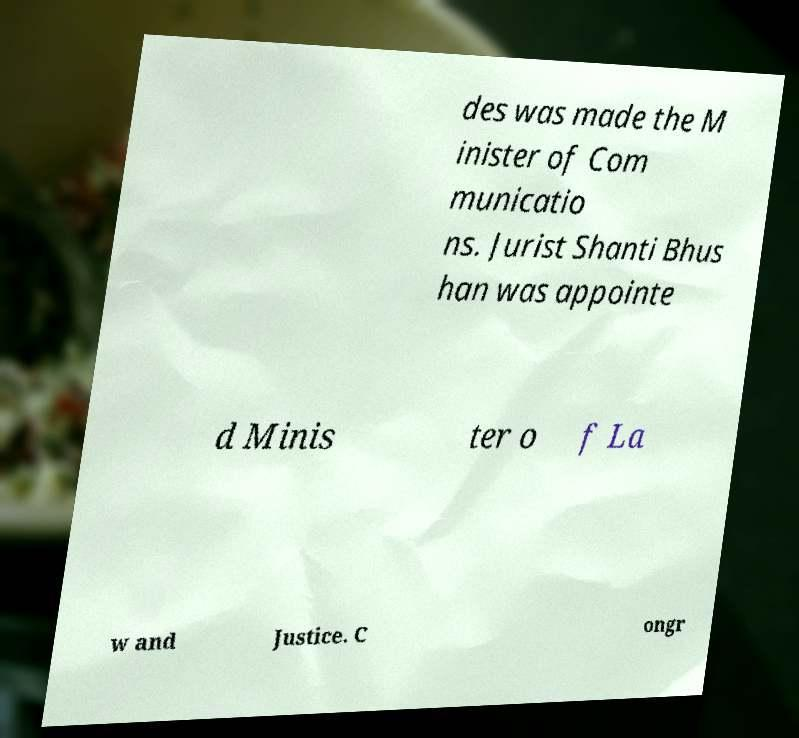Can you read and provide the text displayed in the image?This photo seems to have some interesting text. Can you extract and type it out for me? des was made the M inister of Com municatio ns. Jurist Shanti Bhus han was appointe d Minis ter o f La w and Justice. C ongr 